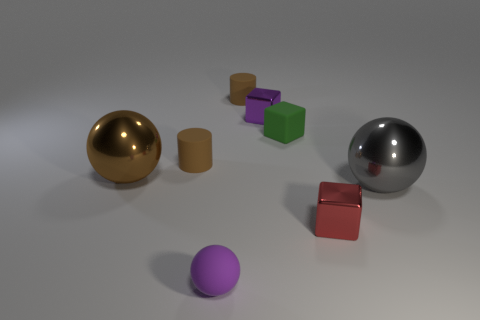Add 1 big shiny things. How many objects exist? 9 Subtract all balls. How many objects are left? 5 Add 2 tiny blue balls. How many tiny blue balls exist? 2 Subtract 0 yellow blocks. How many objects are left? 8 Subtract all blocks. Subtract all brown rubber objects. How many objects are left? 3 Add 4 gray metallic spheres. How many gray metallic spheres are left? 5 